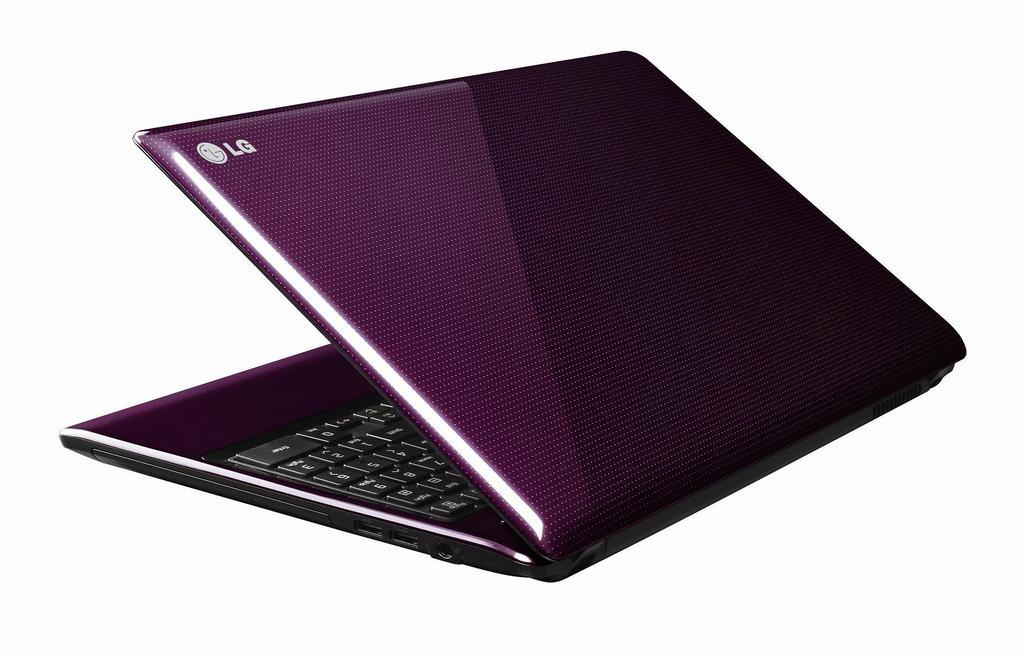What electronic device is visible in the image? There is a laptop in the image. What color is the laptop? The laptop is pink in color. What brand is the laptop? The brand name of the laptop is "LG". How many bells are attached to the laptop in the image? There are no bells attached to the laptop in the image. What type of cat can be seen sitting on the laptop in the image? There is no cat present in the image; it only features a pink "LG" laptop. 